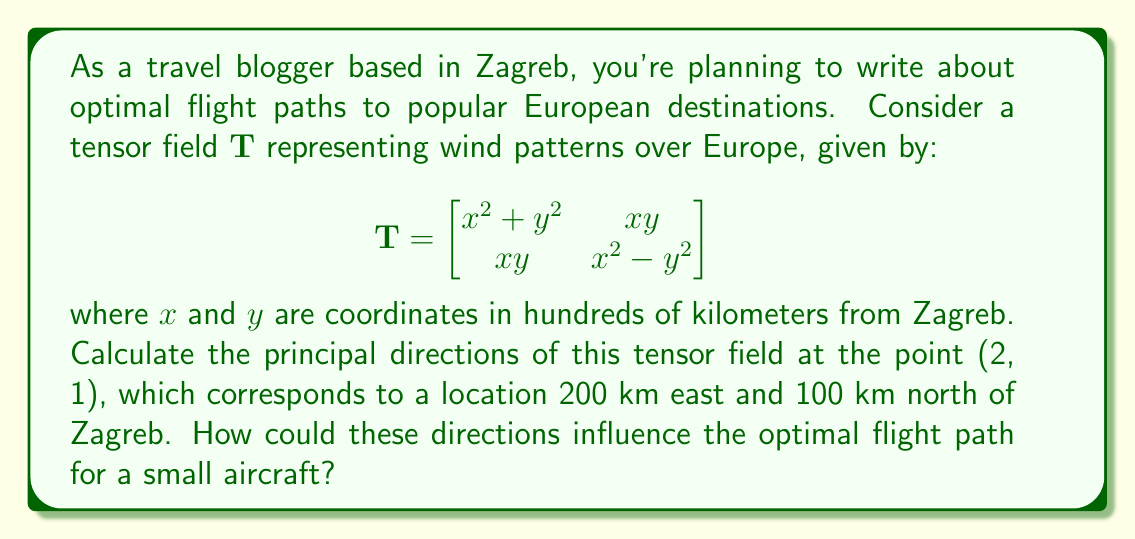Teach me how to tackle this problem. To find the principal directions of the tensor field, we need to follow these steps:

1) First, we evaluate the tensor at the given point (2, 1):

   $$\mathbf{T}_{(2,1)} = \begin{bmatrix}
   2^2 + 1^2 & 2 \cdot 1 \\
   2 \cdot 1 & 2^2 - 1^2
   \end{bmatrix} = \begin{bmatrix}
   5 & 2 \\
   2 & 3
   \end{bmatrix}$$

2) The principal directions are the eigenvectors of this matrix. To find them, we need to solve the characteristic equation:

   $$det(\mathbf{T}_{(2,1)} - \lambda \mathbf{I}) = 0$$

   $$\begin{vmatrix}
   5-\lambda & 2 \\
   2 & 3-\lambda
   \end{vmatrix} = 0$$

   $$(5-\lambda)(3-\lambda) - 4 = 0$$

   $$\lambda^2 - 8\lambda + 11 = 0$$

3) Solving this quadratic equation:

   $$\lambda = \frac{8 \pm \sqrt{64 - 44}}{2} = \frac{8 \pm \sqrt{20}}{2}$$

   $$\lambda_1 = \frac{8 + 2\sqrt{5}}{2} = 4 + \sqrt{5}$$
   $$\lambda_2 = \frac{8 - 2\sqrt{5}}{2} = 4 - \sqrt{5}$$

4) For each eigenvalue, we find the corresponding eigenvector by solving:

   $$(\mathbf{T}_{(2,1)} - \lambda \mathbf{I})\mathbf{v} = \mathbf{0}$$

   For $\lambda_1 = 4 + \sqrt{5}$:

   $$\begin{bmatrix}
   1-\sqrt{5} & 2 \\
   2 & -1-\sqrt{5}
   \end{bmatrix}\begin{bmatrix}
   v_1 \\
   v_2
   \end{bmatrix} = \begin{bmatrix}
   0 \\
   0
   \end{bmatrix}$$

   This gives us: $v_2 = (\sqrt{5}-1)v_1$

   Normalizing, we get: $\mathbf{v}_1 = \frac{1}{\sqrt{6-2\sqrt{5}}}(1, \sqrt{5}-1)$

   Similarly, for $\lambda_2 = 4 - \sqrt{5}$, we get:
   
   $\mathbf{v}_2 = \frac{1}{\sqrt{6+2\sqrt{5}}}(1, -(\sqrt{5}+1))$

5) These principal directions indicate the directions of maximum and minimum stretch in the wind field. For a small aircraft:

   - The direction of $\mathbf{v}_1$ (associated with the larger eigenvalue) represents the direction of strongest winds.
   - The direction of $\mathbf{v}_2$ represents the direction of weakest winds.

   Optimal flight paths would typically try to avoid the direction of strongest winds when flying against them, and align with them when flying with them, while considering fuel efficiency and time.
Answer: Principal directions: $\mathbf{v}_1 = \frac{1}{\sqrt{6-2\sqrt{5}}}(1, \sqrt{5}-1)$, $\mathbf{v}_2 = \frac{1}{\sqrt{6+2\sqrt{5}}}(1, -(\sqrt{5}+1))$. $\mathbf{v}_1$ indicates strongest winds, $\mathbf{v}_2$ weakest winds, influencing optimal flight paths. 